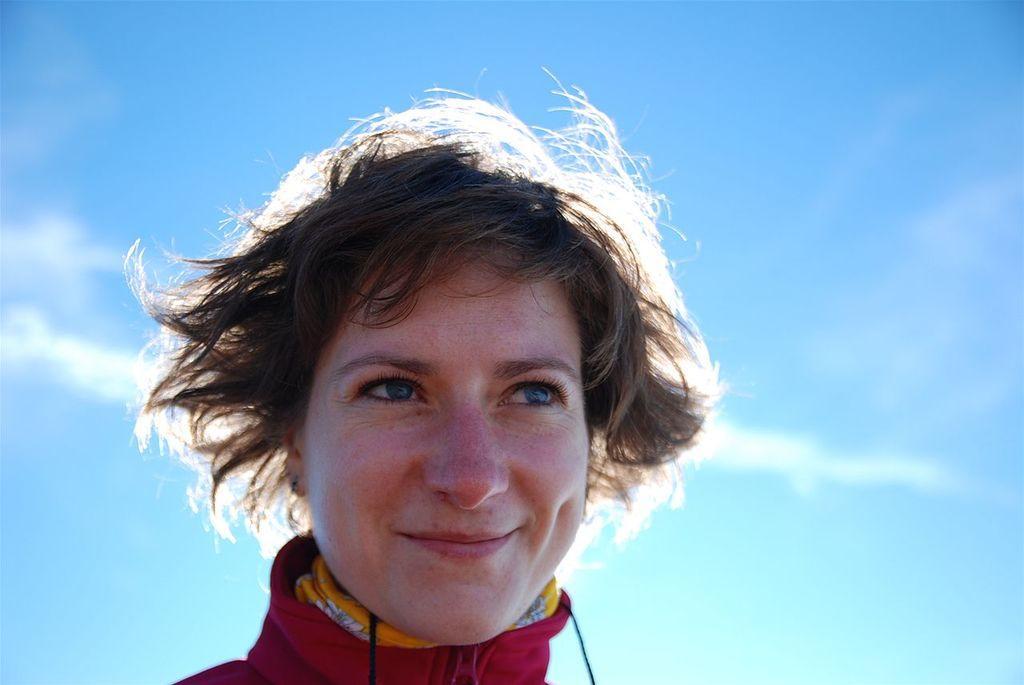In one or two sentences, can you explain what this image depicts? In this picture we can see a person smiling and in the background we can see the sky. 